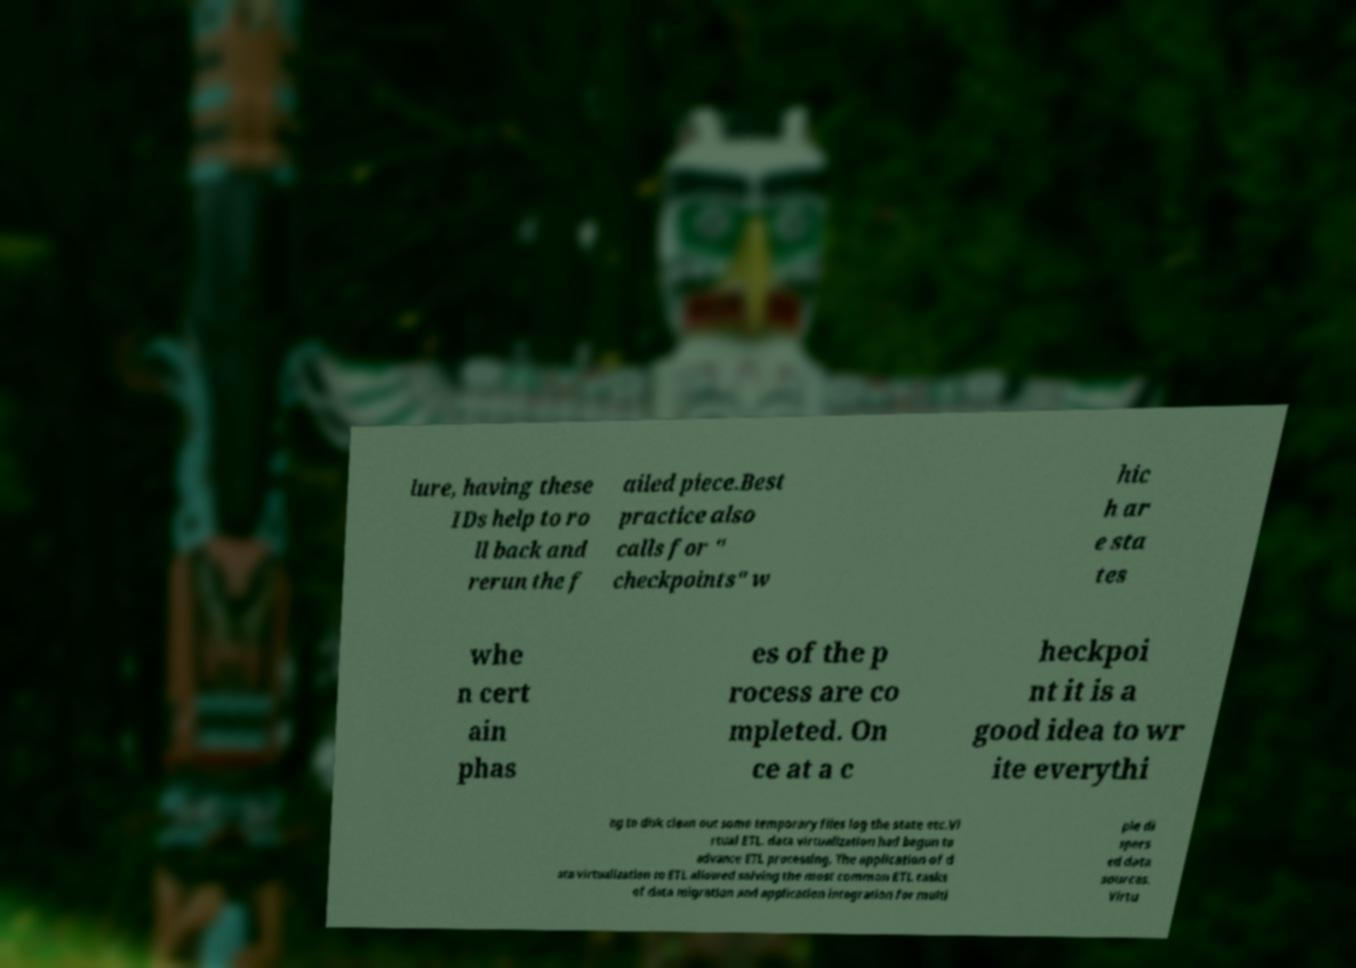Please identify and transcribe the text found in this image. lure, having these IDs help to ro ll back and rerun the f ailed piece.Best practice also calls for " checkpoints" w hic h ar e sta tes whe n cert ain phas es of the p rocess are co mpleted. On ce at a c heckpoi nt it is a good idea to wr ite everythi ng to disk clean out some temporary files log the state etc.Vi rtual ETL. data virtualization had begun to advance ETL processing. The application of d ata virtualization to ETL allowed solving the most common ETL tasks of data migration and application integration for multi ple di spers ed data sources. Virtu 